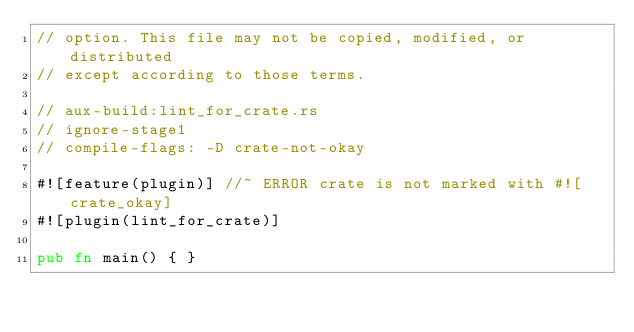Convert code to text. <code><loc_0><loc_0><loc_500><loc_500><_Rust_>// option. This file may not be copied, modified, or distributed
// except according to those terms.

// aux-build:lint_for_crate.rs
// ignore-stage1
// compile-flags: -D crate-not-okay

#![feature(plugin)] //~ ERROR crate is not marked with #![crate_okay]
#![plugin(lint_for_crate)]

pub fn main() { }
</code> 